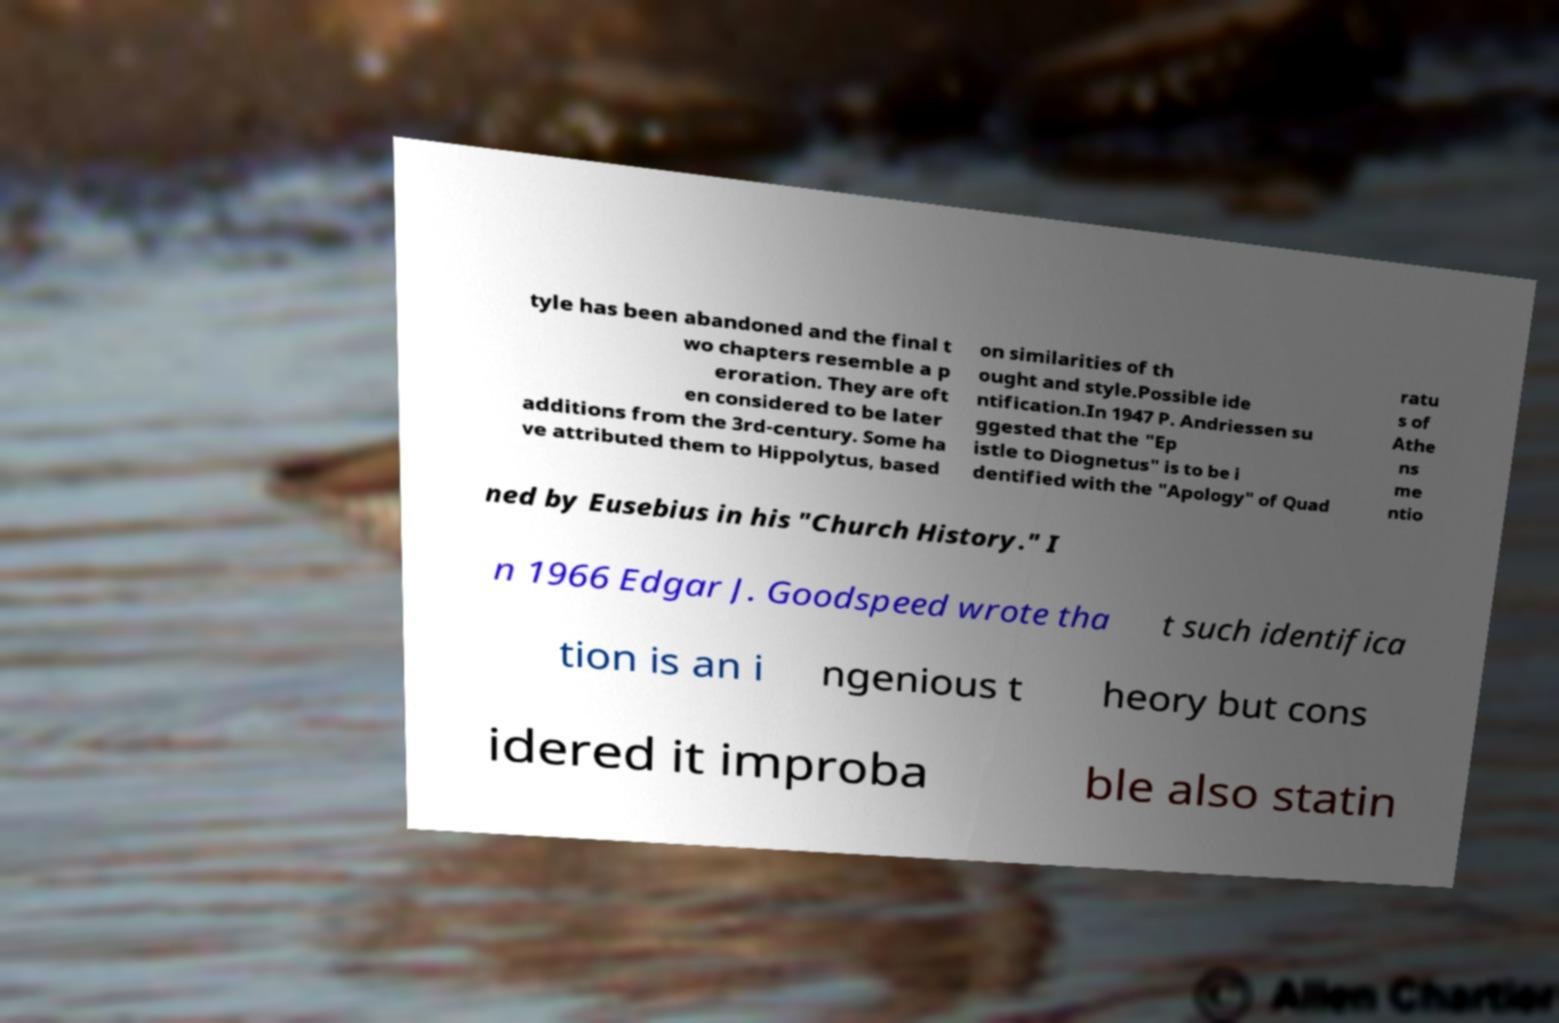Please read and relay the text visible in this image. What does it say? tyle has been abandoned and the final t wo chapters resemble a p eroration. They are oft en considered to be later additions from the 3rd-century. Some ha ve attributed them to Hippolytus, based on similarities of th ought and style.Possible ide ntification.In 1947 P. Andriessen su ggested that the "Ep istle to Diognetus" is to be i dentified with the "Apology" of Quad ratu s of Athe ns me ntio ned by Eusebius in his "Church History." I n 1966 Edgar J. Goodspeed wrote tha t such identifica tion is an i ngenious t heory but cons idered it improba ble also statin 